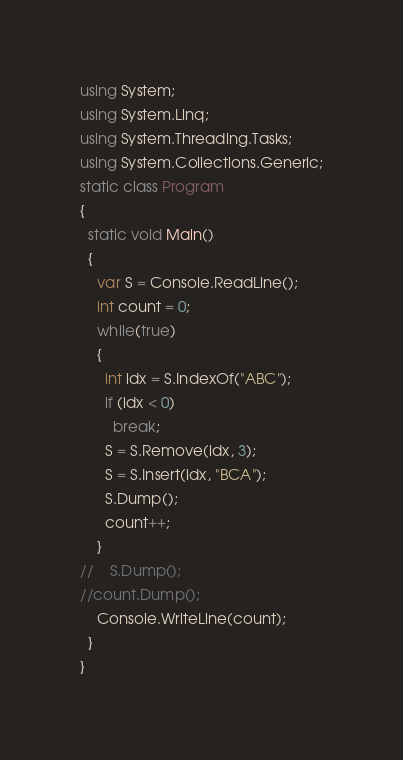<code> <loc_0><loc_0><loc_500><loc_500><_C#_>using System;
using System.Linq;
using System.Threading.Tasks;
using System.Collections.Generic;
static class Program
{
  static void Main()
  {
    var S = Console.ReadLine();
    int count = 0;
    while(true)
    {
      int idx = S.IndexOf("ABC");
      if (idx < 0)
        break;
      S = S.Remove(idx, 3);
      S = S.Insert(idx, "BCA");
      S.Dump();
      count++;
    }
//    S.Dump();
//count.Dump();
    Console.WriteLine(count);
  }
}
</code> 